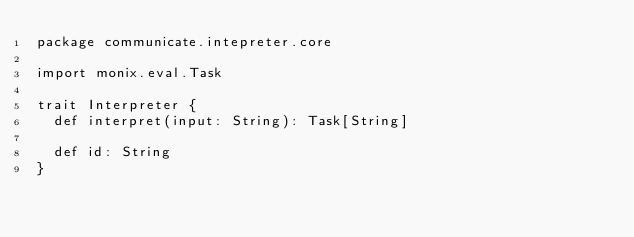<code> <loc_0><loc_0><loc_500><loc_500><_Scala_>package communicate.intepreter.core

import monix.eval.Task

trait Interpreter {
  def interpret(input: String): Task[String]

  def id: String
}
</code> 